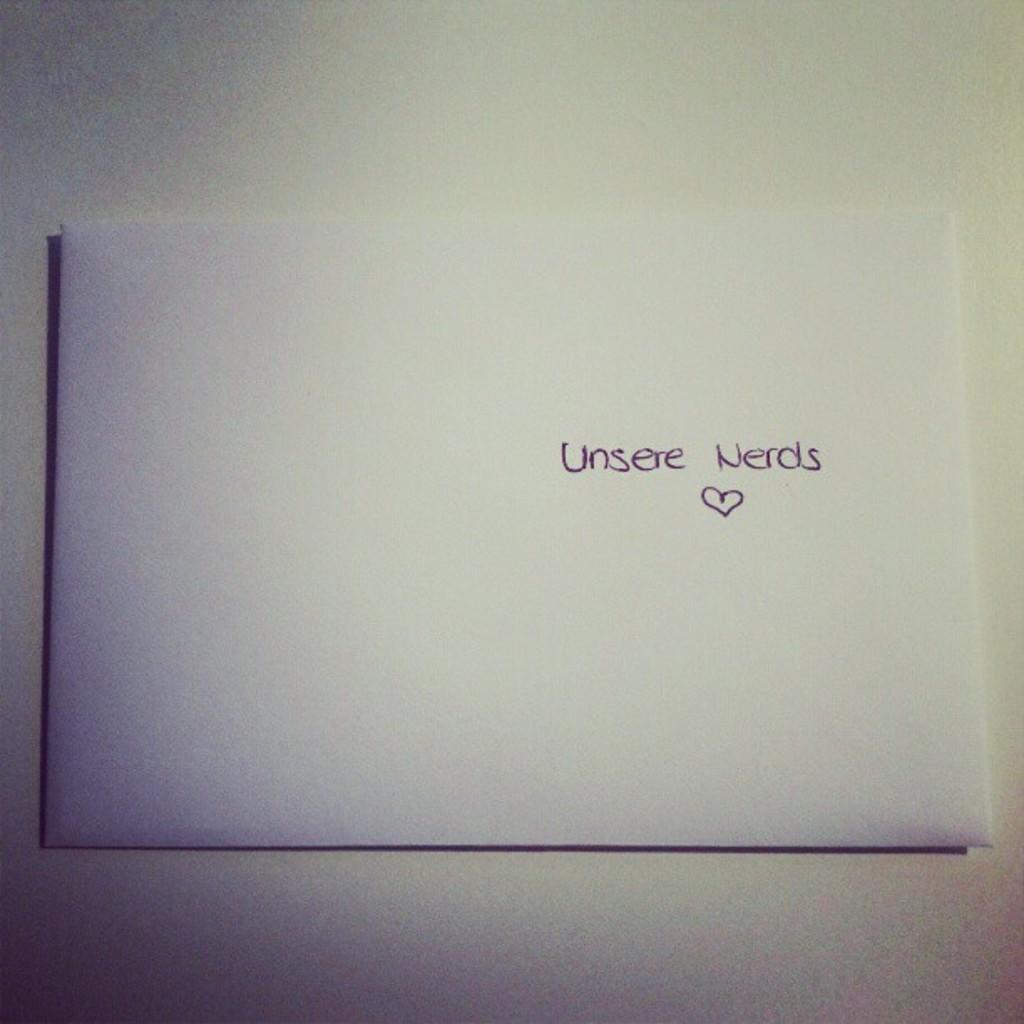What is on the floor in the image? There is a paper on the floor in the image. What can be found on the paper? There is text written on the paper. What type of sweater is the person wearing while observing the exchange in the image? There is no person or exchange present in the image; it only features a paper on the floor with text written on it. 